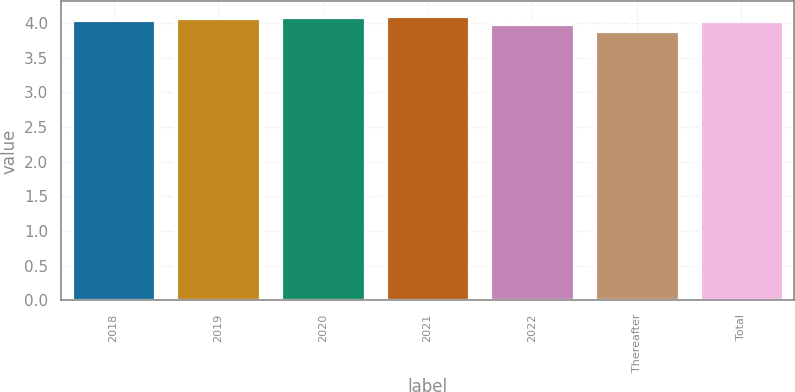<chart> <loc_0><loc_0><loc_500><loc_500><bar_chart><fcel>2018<fcel>2019<fcel>2020<fcel>2021<fcel>2022<fcel>Thereafter<fcel>Total<nl><fcel>4.05<fcel>4.07<fcel>4.09<fcel>4.11<fcel>3.99<fcel>3.88<fcel>4.03<nl></chart> 